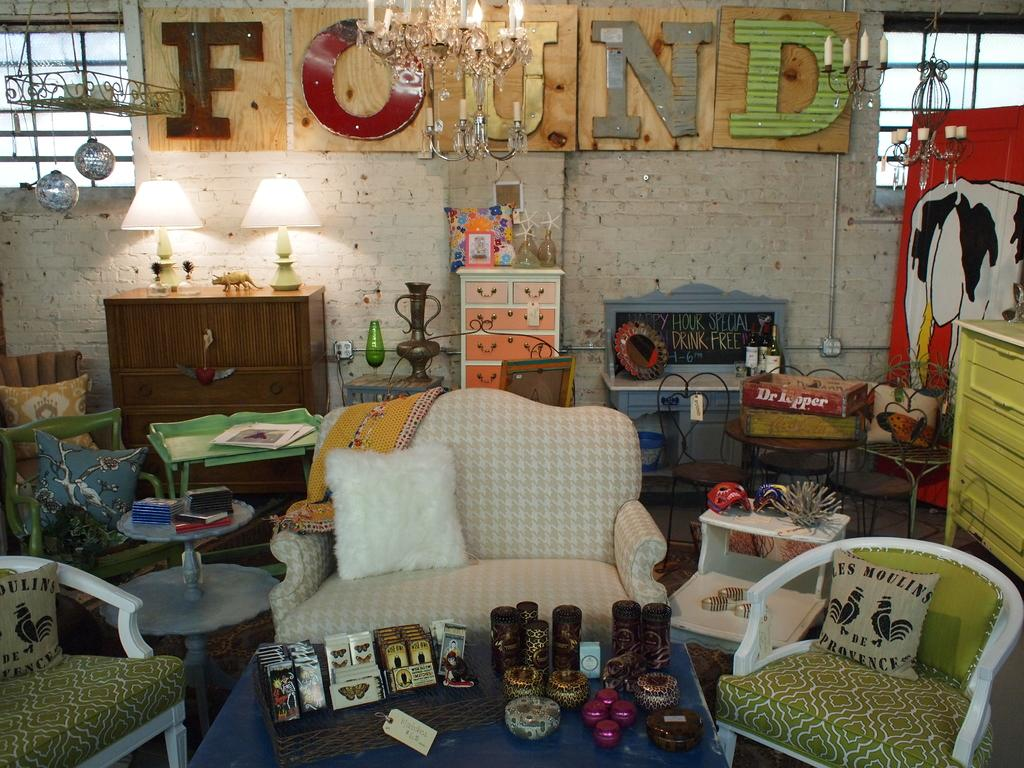What type of furniture is present in the image? There is a sofa, two chairs, and a table in the image. What storage features can be seen in the image? There are drawers, shelves, and cupboards in the image. Where is the plant located in the image? The plant is on the right side of the image. What type of sweater is the rat wearing in the image? There is no rat or sweater present in the image. 